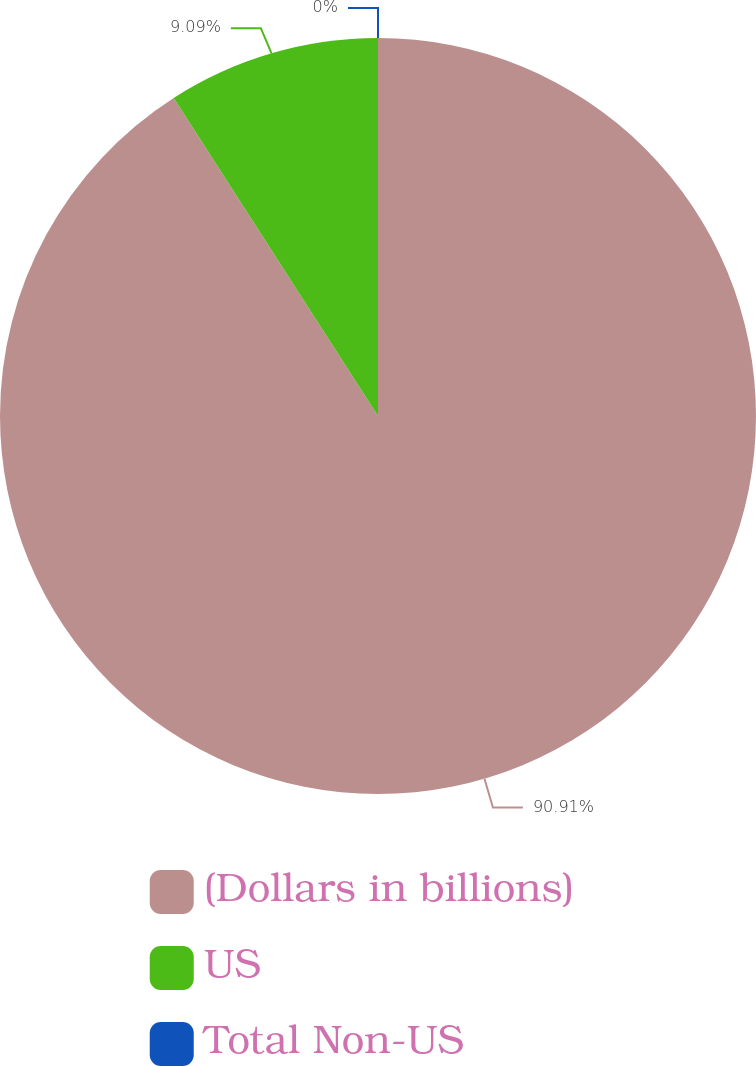Convert chart. <chart><loc_0><loc_0><loc_500><loc_500><pie_chart><fcel>(Dollars in billions)<fcel>US<fcel>Total Non-US<nl><fcel>90.91%<fcel>9.09%<fcel>0.0%<nl></chart> 